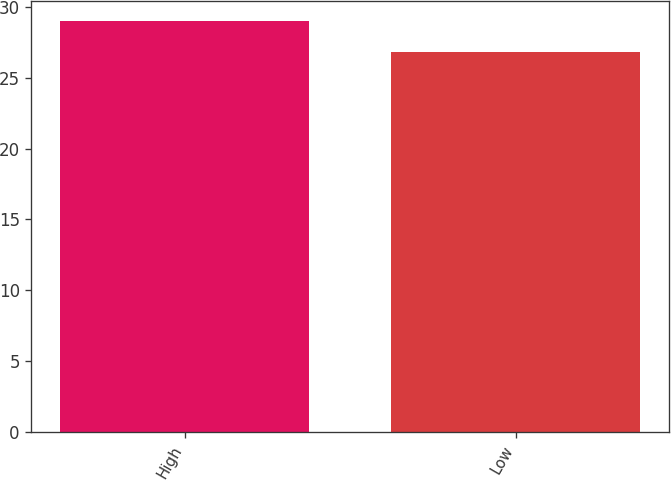Convert chart. <chart><loc_0><loc_0><loc_500><loc_500><bar_chart><fcel>High<fcel>Low<nl><fcel>29<fcel>26.85<nl></chart> 